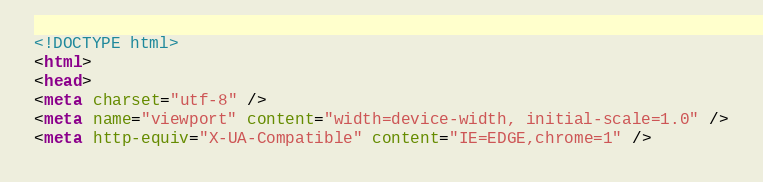<code> <loc_0><loc_0><loc_500><loc_500><_HTML_><!DOCTYPE html>
<html>
<head>
<meta charset="utf-8" />
<meta name="viewport" content="width=device-width, initial-scale=1.0" />
<meta http-equiv="X-UA-Compatible" content="IE=EDGE,chrome=1" /></code> 